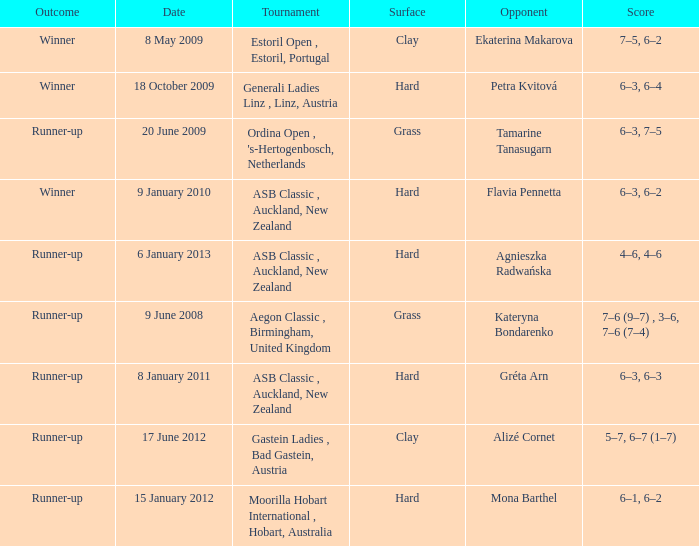What was the score in the tournament against Ekaterina Makarova? 7–5, 6–2. 